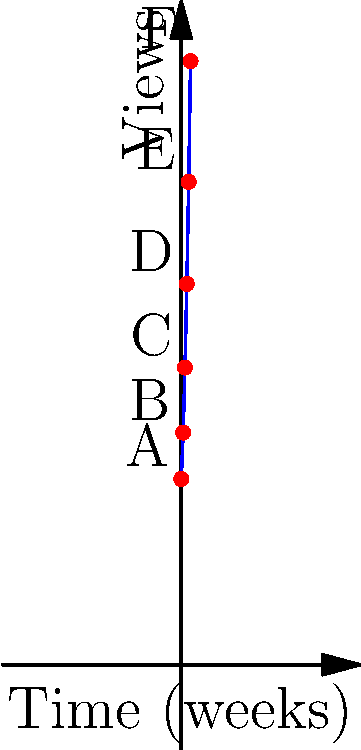The graph shows the number of views for a series of press releases over time. If the trend continues, what will be the approximate increase in views between week 4 (point E) and week 5 (point F)? To solve this problem, we need to follow these steps:

1. Identify the points E and F on the graph, corresponding to weeks 4 and 5.
2. Estimate the y-values (number of views) for these points.
3. Calculate the difference between these y-values.

Let's break it down:

1. Point E corresponds to week 4, and point F to week 5.

2. Estimating y-values:
   - Point E (week 4): approximately 300 views
   - Point F (week 5): approximately 375 views

3. Calculating the difference:
   $375 - 300 = 75$

The increase in views from week 4 to week 5 is approximately 75 views.

This analysis shows an accelerating growth in views over time, which is valuable information for a PR specialist to track the effectiveness of press releases and plan future strategies.
Answer: 75 views 